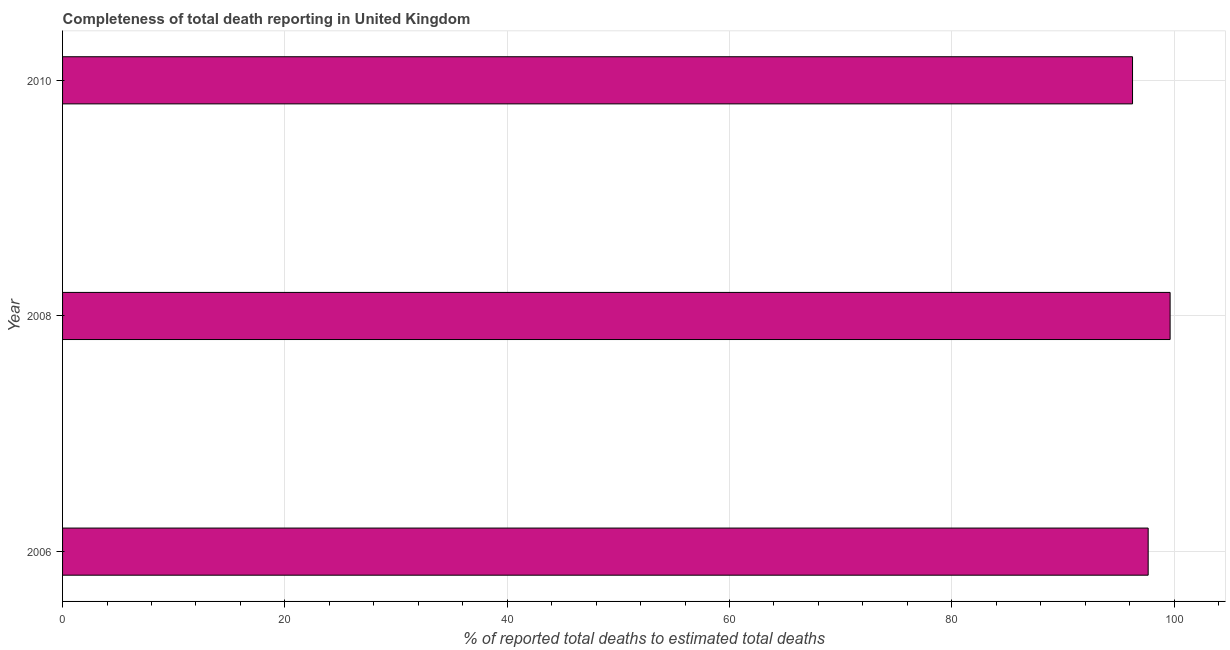What is the title of the graph?
Your answer should be compact. Completeness of total death reporting in United Kingdom. What is the label or title of the X-axis?
Keep it short and to the point. % of reported total deaths to estimated total deaths. What is the completeness of total death reports in 2006?
Give a very brief answer. 97.67. Across all years, what is the maximum completeness of total death reports?
Offer a terse response. 99.65. Across all years, what is the minimum completeness of total death reports?
Your answer should be compact. 96.26. In which year was the completeness of total death reports maximum?
Offer a very short reply. 2008. What is the sum of the completeness of total death reports?
Your response must be concise. 293.58. What is the difference between the completeness of total death reports in 2008 and 2010?
Give a very brief answer. 3.38. What is the average completeness of total death reports per year?
Provide a short and direct response. 97.86. What is the median completeness of total death reports?
Give a very brief answer. 97.67. What is the ratio of the completeness of total death reports in 2006 to that in 2008?
Offer a terse response. 0.98. Is the difference between the completeness of total death reports in 2008 and 2010 greater than the difference between any two years?
Your answer should be compact. Yes. What is the difference between the highest and the second highest completeness of total death reports?
Make the answer very short. 1.97. Is the sum of the completeness of total death reports in 2006 and 2010 greater than the maximum completeness of total death reports across all years?
Keep it short and to the point. Yes. What is the difference between the highest and the lowest completeness of total death reports?
Keep it short and to the point. 3.38. In how many years, is the completeness of total death reports greater than the average completeness of total death reports taken over all years?
Provide a succinct answer. 1. How many bars are there?
Make the answer very short. 3. How many years are there in the graph?
Ensure brevity in your answer.  3. What is the difference between two consecutive major ticks on the X-axis?
Provide a short and direct response. 20. What is the % of reported total deaths to estimated total deaths in 2006?
Keep it short and to the point. 97.67. What is the % of reported total deaths to estimated total deaths in 2008?
Ensure brevity in your answer.  99.65. What is the % of reported total deaths to estimated total deaths in 2010?
Keep it short and to the point. 96.26. What is the difference between the % of reported total deaths to estimated total deaths in 2006 and 2008?
Your answer should be very brief. -1.97. What is the difference between the % of reported total deaths to estimated total deaths in 2006 and 2010?
Your response must be concise. 1.41. What is the difference between the % of reported total deaths to estimated total deaths in 2008 and 2010?
Your answer should be very brief. 3.38. What is the ratio of the % of reported total deaths to estimated total deaths in 2008 to that in 2010?
Provide a short and direct response. 1.03. 